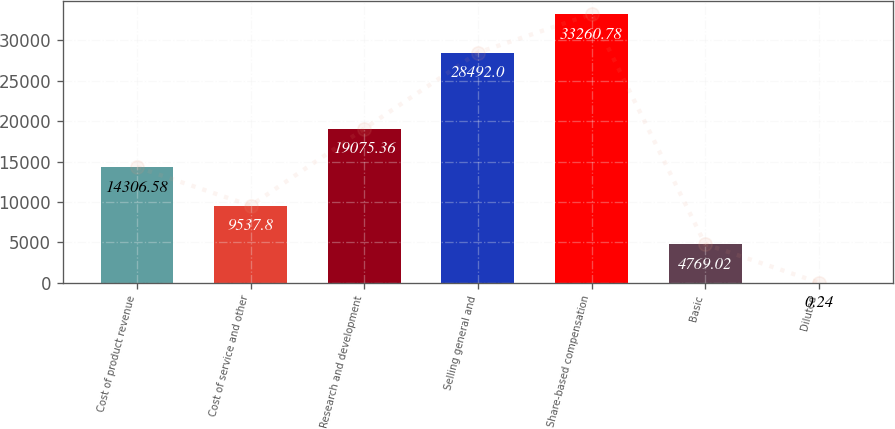Convert chart. <chart><loc_0><loc_0><loc_500><loc_500><bar_chart><fcel>Cost of product revenue<fcel>Cost of service and other<fcel>Research and development<fcel>Selling general and<fcel>Share-based compensation<fcel>Basic<fcel>Diluted<nl><fcel>14306.6<fcel>9537.8<fcel>19075.4<fcel>28492<fcel>33260.8<fcel>4769.02<fcel>0.24<nl></chart> 